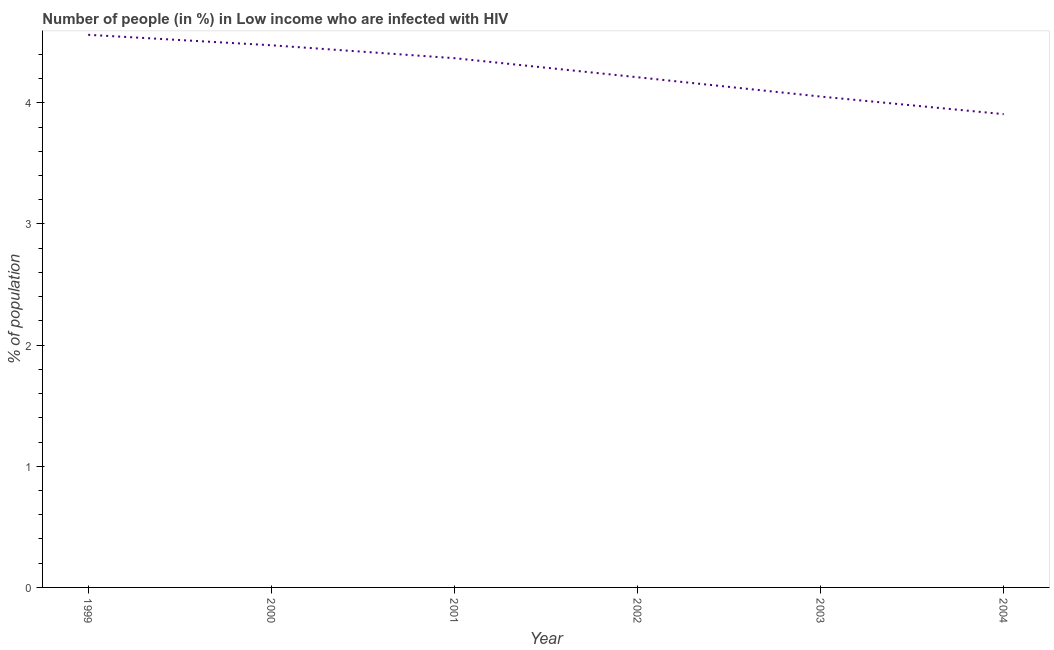What is the number of people infected with hiv in 2002?
Ensure brevity in your answer.  4.21. Across all years, what is the maximum number of people infected with hiv?
Give a very brief answer. 4.56. Across all years, what is the minimum number of people infected with hiv?
Your response must be concise. 3.91. In which year was the number of people infected with hiv maximum?
Keep it short and to the point. 1999. What is the sum of the number of people infected with hiv?
Offer a terse response. 25.57. What is the difference between the number of people infected with hiv in 2002 and 2004?
Your response must be concise. 0.3. What is the average number of people infected with hiv per year?
Provide a short and direct response. 4.26. What is the median number of people infected with hiv?
Provide a succinct answer. 4.29. In how many years, is the number of people infected with hiv greater than 0.8 %?
Your answer should be compact. 6. What is the ratio of the number of people infected with hiv in 2001 to that in 2003?
Make the answer very short. 1.08. Is the difference between the number of people infected with hiv in 2000 and 2003 greater than the difference between any two years?
Your answer should be compact. No. What is the difference between the highest and the second highest number of people infected with hiv?
Your response must be concise. 0.09. What is the difference between the highest and the lowest number of people infected with hiv?
Provide a short and direct response. 0.65. How many years are there in the graph?
Provide a succinct answer. 6. Does the graph contain grids?
Keep it short and to the point. No. What is the title of the graph?
Give a very brief answer. Number of people (in %) in Low income who are infected with HIV. What is the label or title of the Y-axis?
Keep it short and to the point. % of population. What is the % of population in 1999?
Offer a very short reply. 4.56. What is the % of population of 2000?
Ensure brevity in your answer.  4.47. What is the % of population of 2001?
Offer a terse response. 4.37. What is the % of population in 2002?
Your response must be concise. 4.21. What is the % of population in 2003?
Your response must be concise. 4.05. What is the % of population in 2004?
Your answer should be compact. 3.91. What is the difference between the % of population in 1999 and 2000?
Offer a terse response. 0.09. What is the difference between the % of population in 1999 and 2001?
Ensure brevity in your answer.  0.19. What is the difference between the % of population in 1999 and 2002?
Offer a terse response. 0.35. What is the difference between the % of population in 1999 and 2003?
Keep it short and to the point. 0.51. What is the difference between the % of population in 1999 and 2004?
Offer a very short reply. 0.65. What is the difference between the % of population in 2000 and 2001?
Your answer should be compact. 0.11. What is the difference between the % of population in 2000 and 2002?
Your response must be concise. 0.26. What is the difference between the % of population in 2000 and 2003?
Make the answer very short. 0.42. What is the difference between the % of population in 2000 and 2004?
Provide a short and direct response. 0.57. What is the difference between the % of population in 2001 and 2002?
Provide a succinct answer. 0.16. What is the difference between the % of population in 2001 and 2003?
Offer a very short reply. 0.32. What is the difference between the % of population in 2001 and 2004?
Offer a very short reply. 0.46. What is the difference between the % of population in 2002 and 2003?
Your answer should be very brief. 0.16. What is the difference between the % of population in 2002 and 2004?
Keep it short and to the point. 0.3. What is the difference between the % of population in 2003 and 2004?
Offer a terse response. 0.15. What is the ratio of the % of population in 1999 to that in 2001?
Your answer should be very brief. 1.04. What is the ratio of the % of population in 1999 to that in 2002?
Keep it short and to the point. 1.08. What is the ratio of the % of population in 1999 to that in 2003?
Ensure brevity in your answer.  1.13. What is the ratio of the % of population in 1999 to that in 2004?
Give a very brief answer. 1.17. What is the ratio of the % of population in 2000 to that in 2002?
Ensure brevity in your answer.  1.06. What is the ratio of the % of population in 2000 to that in 2003?
Ensure brevity in your answer.  1.1. What is the ratio of the % of population in 2000 to that in 2004?
Your answer should be compact. 1.15. What is the ratio of the % of population in 2001 to that in 2003?
Your answer should be compact. 1.08. What is the ratio of the % of population in 2001 to that in 2004?
Provide a short and direct response. 1.12. What is the ratio of the % of population in 2002 to that in 2003?
Make the answer very short. 1.04. What is the ratio of the % of population in 2002 to that in 2004?
Provide a short and direct response. 1.08. What is the ratio of the % of population in 2003 to that in 2004?
Make the answer very short. 1.04. 